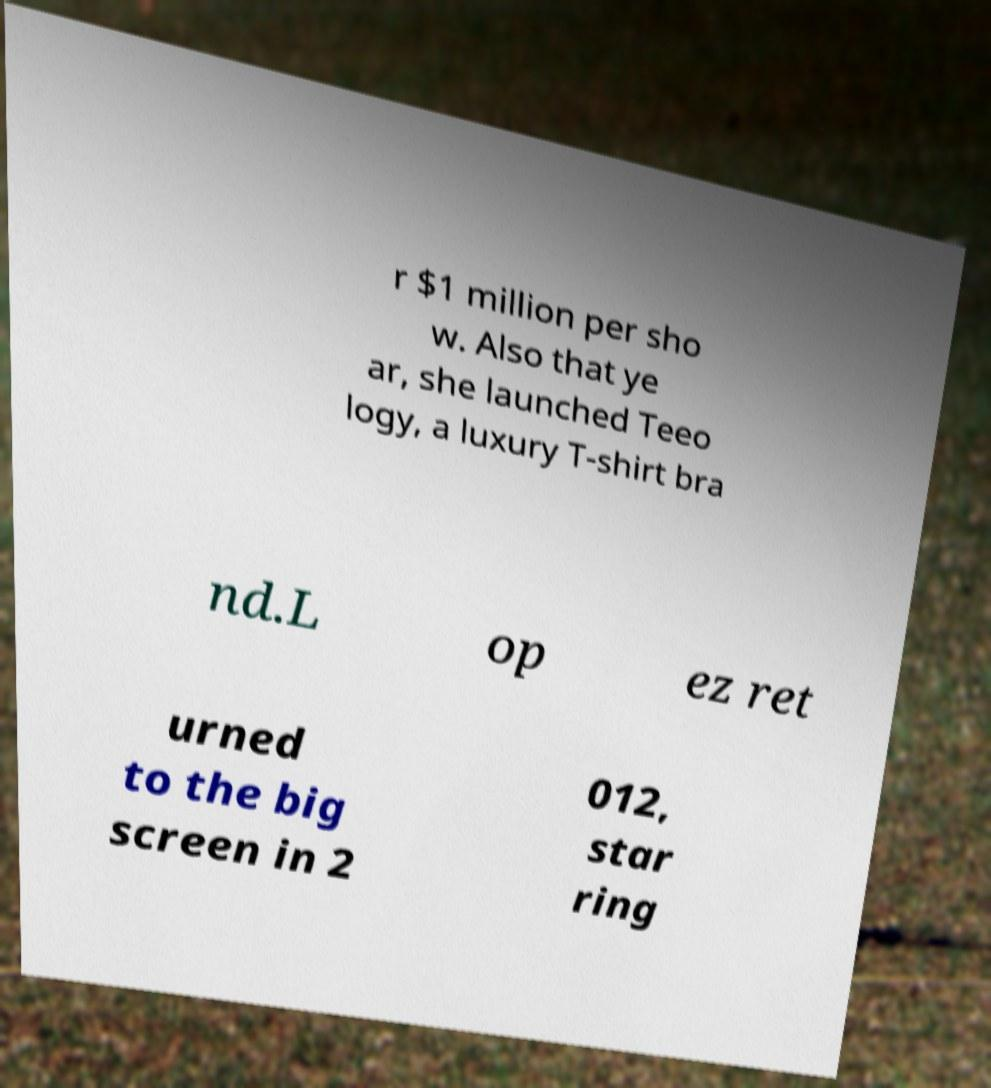Could you extract and type out the text from this image? r $1 million per sho w. Also that ye ar, she launched Teeo logy, a luxury T-shirt bra nd.L op ez ret urned to the big screen in 2 012, star ring 